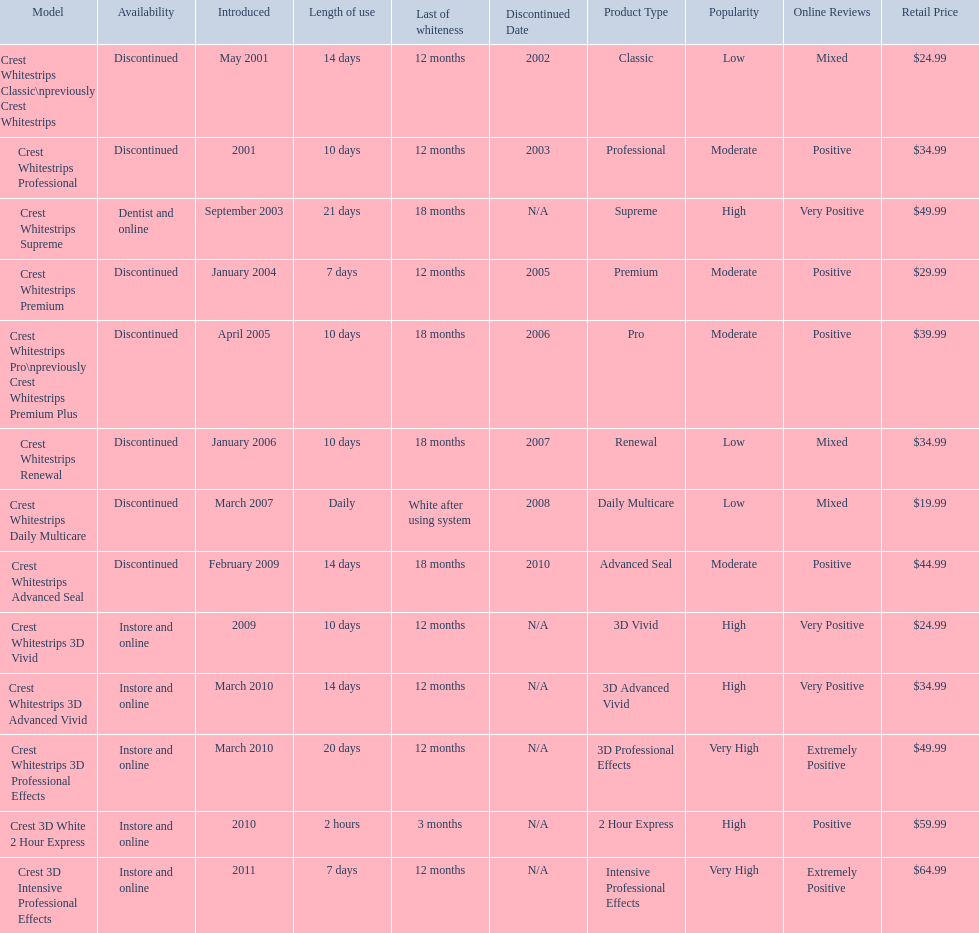What are all the models? Crest Whitestrips Classic\npreviously Crest Whitestrips, Crest Whitestrips Professional, Crest Whitestrips Supreme, Crest Whitestrips Premium, Crest Whitestrips Pro\npreviously Crest Whitestrips Premium Plus, Crest Whitestrips Renewal, Crest Whitestrips Daily Multicare, Crest Whitestrips Advanced Seal, Crest Whitestrips 3D Vivid, Crest Whitestrips 3D Advanced Vivid, Crest Whitestrips 3D Professional Effects, Crest 3D White 2 Hour Express, Crest 3D Intensive Professional Effects. Of these, for which can a ratio be calculated for 'length of use' to 'last of whiteness'? Crest Whitestrips Classic\npreviously Crest Whitestrips, Crest Whitestrips Professional, Crest Whitestrips Supreme, Crest Whitestrips Premium, Crest Whitestrips Pro\npreviously Crest Whitestrips Premium Plus, Crest Whitestrips Renewal, Crest Whitestrips Advanced Seal, Crest Whitestrips 3D Vivid, Crest Whitestrips 3D Advanced Vivid, Crest Whitestrips 3D Professional Effects, Crest 3D White 2 Hour Express, Crest 3D Intensive Professional Effects. Which has the highest ratio? Crest Whitestrips Supreme. 